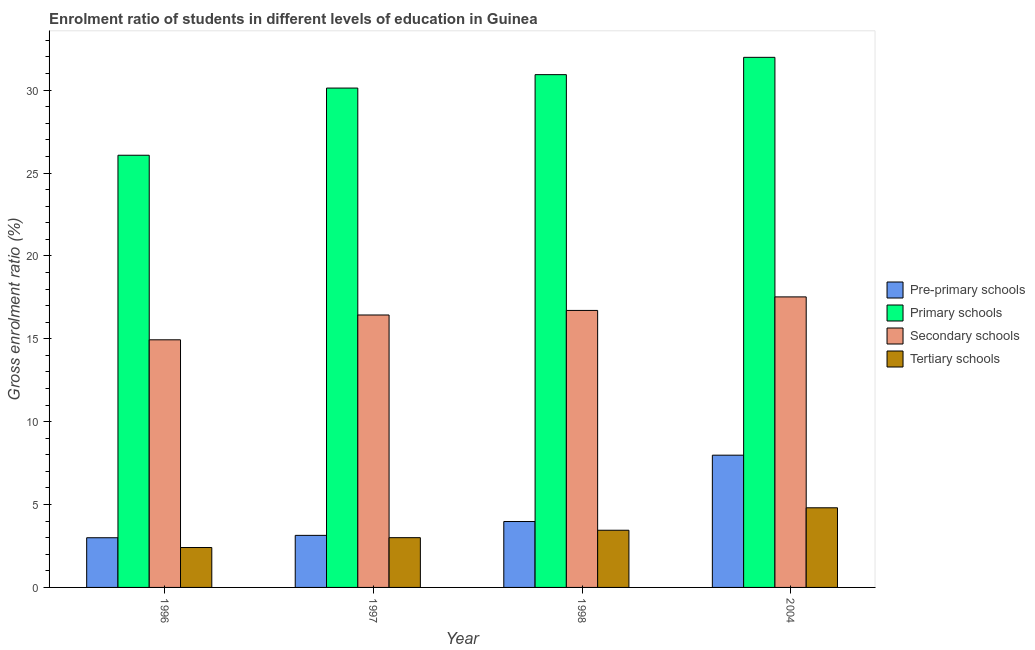Are the number of bars per tick equal to the number of legend labels?
Give a very brief answer. Yes. How many bars are there on the 4th tick from the left?
Provide a succinct answer. 4. How many bars are there on the 4th tick from the right?
Ensure brevity in your answer.  4. What is the label of the 2nd group of bars from the left?
Your answer should be very brief. 1997. In how many cases, is the number of bars for a given year not equal to the number of legend labels?
Your answer should be compact. 0. What is the gross enrolment ratio in secondary schools in 2004?
Your answer should be very brief. 17.53. Across all years, what is the maximum gross enrolment ratio in primary schools?
Provide a succinct answer. 31.98. Across all years, what is the minimum gross enrolment ratio in secondary schools?
Make the answer very short. 14.94. In which year was the gross enrolment ratio in primary schools minimum?
Make the answer very short. 1996. What is the total gross enrolment ratio in tertiary schools in the graph?
Provide a short and direct response. 13.66. What is the difference between the gross enrolment ratio in secondary schools in 1996 and that in 1998?
Your answer should be compact. -1.77. What is the difference between the gross enrolment ratio in primary schools in 2004 and the gross enrolment ratio in tertiary schools in 1996?
Your answer should be very brief. 5.91. What is the average gross enrolment ratio in pre-primary schools per year?
Your response must be concise. 4.52. In how many years, is the gross enrolment ratio in secondary schools greater than 22 %?
Keep it short and to the point. 0. What is the ratio of the gross enrolment ratio in primary schools in 1998 to that in 2004?
Offer a terse response. 0.97. What is the difference between the highest and the second highest gross enrolment ratio in tertiary schools?
Provide a short and direct response. 1.35. What is the difference between the highest and the lowest gross enrolment ratio in secondary schools?
Offer a very short reply. 2.59. What does the 1st bar from the left in 1996 represents?
Ensure brevity in your answer.  Pre-primary schools. What does the 3rd bar from the right in 2004 represents?
Offer a very short reply. Primary schools. Is it the case that in every year, the sum of the gross enrolment ratio in pre-primary schools and gross enrolment ratio in primary schools is greater than the gross enrolment ratio in secondary schools?
Offer a very short reply. Yes. How many bars are there?
Give a very brief answer. 16. How many years are there in the graph?
Make the answer very short. 4. What is the difference between two consecutive major ticks on the Y-axis?
Your answer should be compact. 5. Are the values on the major ticks of Y-axis written in scientific E-notation?
Offer a very short reply. No. What is the title of the graph?
Provide a succinct answer. Enrolment ratio of students in different levels of education in Guinea. Does "Korea" appear as one of the legend labels in the graph?
Give a very brief answer. No. What is the label or title of the X-axis?
Your answer should be compact. Year. What is the label or title of the Y-axis?
Give a very brief answer. Gross enrolment ratio (%). What is the Gross enrolment ratio (%) in Pre-primary schools in 1996?
Make the answer very short. 3. What is the Gross enrolment ratio (%) in Primary schools in 1996?
Your answer should be very brief. 26.07. What is the Gross enrolment ratio (%) of Secondary schools in 1996?
Make the answer very short. 14.94. What is the Gross enrolment ratio (%) of Tertiary schools in 1996?
Your answer should be very brief. 2.41. What is the Gross enrolment ratio (%) of Pre-primary schools in 1997?
Keep it short and to the point. 3.14. What is the Gross enrolment ratio (%) in Primary schools in 1997?
Provide a succinct answer. 30.12. What is the Gross enrolment ratio (%) of Secondary schools in 1997?
Make the answer very short. 16.44. What is the Gross enrolment ratio (%) of Tertiary schools in 1997?
Provide a succinct answer. 3. What is the Gross enrolment ratio (%) in Pre-primary schools in 1998?
Offer a terse response. 3.98. What is the Gross enrolment ratio (%) in Primary schools in 1998?
Make the answer very short. 30.93. What is the Gross enrolment ratio (%) in Secondary schools in 1998?
Give a very brief answer. 16.71. What is the Gross enrolment ratio (%) of Tertiary schools in 1998?
Your response must be concise. 3.45. What is the Gross enrolment ratio (%) of Pre-primary schools in 2004?
Your answer should be compact. 7.98. What is the Gross enrolment ratio (%) in Primary schools in 2004?
Provide a short and direct response. 31.98. What is the Gross enrolment ratio (%) in Secondary schools in 2004?
Make the answer very short. 17.53. What is the Gross enrolment ratio (%) of Tertiary schools in 2004?
Your answer should be compact. 4.8. Across all years, what is the maximum Gross enrolment ratio (%) of Pre-primary schools?
Offer a terse response. 7.98. Across all years, what is the maximum Gross enrolment ratio (%) of Primary schools?
Offer a very short reply. 31.98. Across all years, what is the maximum Gross enrolment ratio (%) of Secondary schools?
Offer a terse response. 17.53. Across all years, what is the maximum Gross enrolment ratio (%) in Tertiary schools?
Keep it short and to the point. 4.8. Across all years, what is the minimum Gross enrolment ratio (%) in Pre-primary schools?
Provide a succinct answer. 3. Across all years, what is the minimum Gross enrolment ratio (%) in Primary schools?
Your answer should be very brief. 26.07. Across all years, what is the minimum Gross enrolment ratio (%) of Secondary schools?
Your answer should be compact. 14.94. Across all years, what is the minimum Gross enrolment ratio (%) in Tertiary schools?
Your response must be concise. 2.41. What is the total Gross enrolment ratio (%) of Pre-primary schools in the graph?
Provide a short and direct response. 18.09. What is the total Gross enrolment ratio (%) of Primary schools in the graph?
Ensure brevity in your answer.  119.11. What is the total Gross enrolment ratio (%) of Secondary schools in the graph?
Your answer should be compact. 65.61. What is the total Gross enrolment ratio (%) of Tertiary schools in the graph?
Make the answer very short. 13.66. What is the difference between the Gross enrolment ratio (%) of Pre-primary schools in 1996 and that in 1997?
Offer a very short reply. -0.14. What is the difference between the Gross enrolment ratio (%) of Primary schools in 1996 and that in 1997?
Offer a terse response. -4.05. What is the difference between the Gross enrolment ratio (%) in Secondary schools in 1996 and that in 1997?
Ensure brevity in your answer.  -1.5. What is the difference between the Gross enrolment ratio (%) in Tertiary schools in 1996 and that in 1997?
Provide a succinct answer. -0.59. What is the difference between the Gross enrolment ratio (%) in Pre-primary schools in 1996 and that in 1998?
Offer a terse response. -0.98. What is the difference between the Gross enrolment ratio (%) in Primary schools in 1996 and that in 1998?
Provide a short and direct response. -4.86. What is the difference between the Gross enrolment ratio (%) of Secondary schools in 1996 and that in 1998?
Your response must be concise. -1.77. What is the difference between the Gross enrolment ratio (%) of Tertiary schools in 1996 and that in 1998?
Make the answer very short. -1.04. What is the difference between the Gross enrolment ratio (%) in Pre-primary schools in 1996 and that in 2004?
Offer a terse response. -4.98. What is the difference between the Gross enrolment ratio (%) of Primary schools in 1996 and that in 2004?
Your answer should be very brief. -5.91. What is the difference between the Gross enrolment ratio (%) of Secondary schools in 1996 and that in 2004?
Your answer should be compact. -2.59. What is the difference between the Gross enrolment ratio (%) in Tertiary schools in 1996 and that in 2004?
Provide a short and direct response. -2.4. What is the difference between the Gross enrolment ratio (%) of Pre-primary schools in 1997 and that in 1998?
Your answer should be compact. -0.83. What is the difference between the Gross enrolment ratio (%) in Primary schools in 1997 and that in 1998?
Give a very brief answer. -0.81. What is the difference between the Gross enrolment ratio (%) of Secondary schools in 1997 and that in 1998?
Offer a very short reply. -0.27. What is the difference between the Gross enrolment ratio (%) in Tertiary schools in 1997 and that in 1998?
Offer a terse response. -0.45. What is the difference between the Gross enrolment ratio (%) of Pre-primary schools in 1997 and that in 2004?
Provide a short and direct response. -4.84. What is the difference between the Gross enrolment ratio (%) in Primary schools in 1997 and that in 2004?
Provide a short and direct response. -1.85. What is the difference between the Gross enrolment ratio (%) in Secondary schools in 1997 and that in 2004?
Offer a very short reply. -1.09. What is the difference between the Gross enrolment ratio (%) in Tertiary schools in 1997 and that in 2004?
Your answer should be compact. -1.8. What is the difference between the Gross enrolment ratio (%) in Pre-primary schools in 1998 and that in 2004?
Your response must be concise. -4. What is the difference between the Gross enrolment ratio (%) of Primary schools in 1998 and that in 2004?
Provide a short and direct response. -1.04. What is the difference between the Gross enrolment ratio (%) of Secondary schools in 1998 and that in 2004?
Provide a short and direct response. -0.82. What is the difference between the Gross enrolment ratio (%) in Tertiary schools in 1998 and that in 2004?
Keep it short and to the point. -1.35. What is the difference between the Gross enrolment ratio (%) in Pre-primary schools in 1996 and the Gross enrolment ratio (%) in Primary schools in 1997?
Offer a very short reply. -27.13. What is the difference between the Gross enrolment ratio (%) of Pre-primary schools in 1996 and the Gross enrolment ratio (%) of Secondary schools in 1997?
Offer a terse response. -13.44. What is the difference between the Gross enrolment ratio (%) in Pre-primary schools in 1996 and the Gross enrolment ratio (%) in Tertiary schools in 1997?
Your response must be concise. -0. What is the difference between the Gross enrolment ratio (%) in Primary schools in 1996 and the Gross enrolment ratio (%) in Secondary schools in 1997?
Your response must be concise. 9.64. What is the difference between the Gross enrolment ratio (%) in Primary schools in 1996 and the Gross enrolment ratio (%) in Tertiary schools in 1997?
Provide a succinct answer. 23.07. What is the difference between the Gross enrolment ratio (%) in Secondary schools in 1996 and the Gross enrolment ratio (%) in Tertiary schools in 1997?
Your response must be concise. 11.94. What is the difference between the Gross enrolment ratio (%) in Pre-primary schools in 1996 and the Gross enrolment ratio (%) in Primary schools in 1998?
Give a very brief answer. -27.94. What is the difference between the Gross enrolment ratio (%) in Pre-primary schools in 1996 and the Gross enrolment ratio (%) in Secondary schools in 1998?
Give a very brief answer. -13.71. What is the difference between the Gross enrolment ratio (%) of Pre-primary schools in 1996 and the Gross enrolment ratio (%) of Tertiary schools in 1998?
Keep it short and to the point. -0.45. What is the difference between the Gross enrolment ratio (%) in Primary schools in 1996 and the Gross enrolment ratio (%) in Secondary schools in 1998?
Your answer should be very brief. 9.36. What is the difference between the Gross enrolment ratio (%) in Primary schools in 1996 and the Gross enrolment ratio (%) in Tertiary schools in 1998?
Offer a terse response. 22.62. What is the difference between the Gross enrolment ratio (%) in Secondary schools in 1996 and the Gross enrolment ratio (%) in Tertiary schools in 1998?
Provide a short and direct response. 11.49. What is the difference between the Gross enrolment ratio (%) of Pre-primary schools in 1996 and the Gross enrolment ratio (%) of Primary schools in 2004?
Make the answer very short. -28.98. What is the difference between the Gross enrolment ratio (%) of Pre-primary schools in 1996 and the Gross enrolment ratio (%) of Secondary schools in 2004?
Make the answer very short. -14.53. What is the difference between the Gross enrolment ratio (%) of Pre-primary schools in 1996 and the Gross enrolment ratio (%) of Tertiary schools in 2004?
Offer a terse response. -1.81. What is the difference between the Gross enrolment ratio (%) of Primary schools in 1996 and the Gross enrolment ratio (%) of Secondary schools in 2004?
Your answer should be very brief. 8.55. What is the difference between the Gross enrolment ratio (%) in Primary schools in 1996 and the Gross enrolment ratio (%) in Tertiary schools in 2004?
Make the answer very short. 21.27. What is the difference between the Gross enrolment ratio (%) in Secondary schools in 1996 and the Gross enrolment ratio (%) in Tertiary schools in 2004?
Provide a succinct answer. 10.13. What is the difference between the Gross enrolment ratio (%) in Pre-primary schools in 1997 and the Gross enrolment ratio (%) in Primary schools in 1998?
Your answer should be very brief. -27.79. What is the difference between the Gross enrolment ratio (%) of Pre-primary schools in 1997 and the Gross enrolment ratio (%) of Secondary schools in 1998?
Offer a very short reply. -13.57. What is the difference between the Gross enrolment ratio (%) of Pre-primary schools in 1997 and the Gross enrolment ratio (%) of Tertiary schools in 1998?
Offer a terse response. -0.31. What is the difference between the Gross enrolment ratio (%) of Primary schools in 1997 and the Gross enrolment ratio (%) of Secondary schools in 1998?
Make the answer very short. 13.41. What is the difference between the Gross enrolment ratio (%) of Primary schools in 1997 and the Gross enrolment ratio (%) of Tertiary schools in 1998?
Give a very brief answer. 26.67. What is the difference between the Gross enrolment ratio (%) in Secondary schools in 1997 and the Gross enrolment ratio (%) in Tertiary schools in 1998?
Keep it short and to the point. 12.98. What is the difference between the Gross enrolment ratio (%) of Pre-primary schools in 1997 and the Gross enrolment ratio (%) of Primary schools in 2004?
Your answer should be compact. -28.84. What is the difference between the Gross enrolment ratio (%) of Pre-primary schools in 1997 and the Gross enrolment ratio (%) of Secondary schools in 2004?
Keep it short and to the point. -14.39. What is the difference between the Gross enrolment ratio (%) of Pre-primary schools in 1997 and the Gross enrolment ratio (%) of Tertiary schools in 2004?
Provide a short and direct response. -1.66. What is the difference between the Gross enrolment ratio (%) of Primary schools in 1997 and the Gross enrolment ratio (%) of Secondary schools in 2004?
Your answer should be very brief. 12.6. What is the difference between the Gross enrolment ratio (%) of Primary schools in 1997 and the Gross enrolment ratio (%) of Tertiary schools in 2004?
Offer a terse response. 25.32. What is the difference between the Gross enrolment ratio (%) in Secondary schools in 1997 and the Gross enrolment ratio (%) in Tertiary schools in 2004?
Offer a very short reply. 11.63. What is the difference between the Gross enrolment ratio (%) in Pre-primary schools in 1998 and the Gross enrolment ratio (%) in Primary schools in 2004?
Provide a short and direct response. -28. What is the difference between the Gross enrolment ratio (%) in Pre-primary schools in 1998 and the Gross enrolment ratio (%) in Secondary schools in 2004?
Provide a short and direct response. -13.55. What is the difference between the Gross enrolment ratio (%) in Pre-primary schools in 1998 and the Gross enrolment ratio (%) in Tertiary schools in 2004?
Offer a terse response. -0.83. What is the difference between the Gross enrolment ratio (%) in Primary schools in 1998 and the Gross enrolment ratio (%) in Secondary schools in 2004?
Make the answer very short. 13.41. What is the difference between the Gross enrolment ratio (%) of Primary schools in 1998 and the Gross enrolment ratio (%) of Tertiary schools in 2004?
Give a very brief answer. 26.13. What is the difference between the Gross enrolment ratio (%) in Secondary schools in 1998 and the Gross enrolment ratio (%) in Tertiary schools in 2004?
Ensure brevity in your answer.  11.91. What is the average Gross enrolment ratio (%) in Pre-primary schools per year?
Your response must be concise. 4.52. What is the average Gross enrolment ratio (%) of Primary schools per year?
Offer a very short reply. 29.78. What is the average Gross enrolment ratio (%) in Secondary schools per year?
Provide a succinct answer. 16.4. What is the average Gross enrolment ratio (%) of Tertiary schools per year?
Provide a succinct answer. 3.42. In the year 1996, what is the difference between the Gross enrolment ratio (%) of Pre-primary schools and Gross enrolment ratio (%) of Primary schools?
Your answer should be very brief. -23.07. In the year 1996, what is the difference between the Gross enrolment ratio (%) of Pre-primary schools and Gross enrolment ratio (%) of Secondary schools?
Offer a very short reply. -11.94. In the year 1996, what is the difference between the Gross enrolment ratio (%) in Pre-primary schools and Gross enrolment ratio (%) in Tertiary schools?
Offer a very short reply. 0.59. In the year 1996, what is the difference between the Gross enrolment ratio (%) in Primary schools and Gross enrolment ratio (%) in Secondary schools?
Provide a succinct answer. 11.13. In the year 1996, what is the difference between the Gross enrolment ratio (%) in Primary schools and Gross enrolment ratio (%) in Tertiary schools?
Make the answer very short. 23.66. In the year 1996, what is the difference between the Gross enrolment ratio (%) of Secondary schools and Gross enrolment ratio (%) of Tertiary schools?
Ensure brevity in your answer.  12.53. In the year 1997, what is the difference between the Gross enrolment ratio (%) in Pre-primary schools and Gross enrolment ratio (%) in Primary schools?
Give a very brief answer. -26.98. In the year 1997, what is the difference between the Gross enrolment ratio (%) in Pre-primary schools and Gross enrolment ratio (%) in Secondary schools?
Your answer should be very brief. -13.29. In the year 1997, what is the difference between the Gross enrolment ratio (%) in Pre-primary schools and Gross enrolment ratio (%) in Tertiary schools?
Ensure brevity in your answer.  0.14. In the year 1997, what is the difference between the Gross enrolment ratio (%) in Primary schools and Gross enrolment ratio (%) in Secondary schools?
Ensure brevity in your answer.  13.69. In the year 1997, what is the difference between the Gross enrolment ratio (%) of Primary schools and Gross enrolment ratio (%) of Tertiary schools?
Your answer should be compact. 27.12. In the year 1997, what is the difference between the Gross enrolment ratio (%) in Secondary schools and Gross enrolment ratio (%) in Tertiary schools?
Ensure brevity in your answer.  13.43. In the year 1998, what is the difference between the Gross enrolment ratio (%) in Pre-primary schools and Gross enrolment ratio (%) in Primary schools?
Your answer should be very brief. -26.96. In the year 1998, what is the difference between the Gross enrolment ratio (%) of Pre-primary schools and Gross enrolment ratio (%) of Secondary schools?
Give a very brief answer. -12.73. In the year 1998, what is the difference between the Gross enrolment ratio (%) in Pre-primary schools and Gross enrolment ratio (%) in Tertiary schools?
Ensure brevity in your answer.  0.53. In the year 1998, what is the difference between the Gross enrolment ratio (%) in Primary schools and Gross enrolment ratio (%) in Secondary schools?
Give a very brief answer. 14.22. In the year 1998, what is the difference between the Gross enrolment ratio (%) of Primary schools and Gross enrolment ratio (%) of Tertiary schools?
Your response must be concise. 27.48. In the year 1998, what is the difference between the Gross enrolment ratio (%) of Secondary schools and Gross enrolment ratio (%) of Tertiary schools?
Give a very brief answer. 13.26. In the year 2004, what is the difference between the Gross enrolment ratio (%) of Pre-primary schools and Gross enrolment ratio (%) of Primary schools?
Your answer should be very brief. -24. In the year 2004, what is the difference between the Gross enrolment ratio (%) in Pre-primary schools and Gross enrolment ratio (%) in Secondary schools?
Your response must be concise. -9.55. In the year 2004, what is the difference between the Gross enrolment ratio (%) of Pre-primary schools and Gross enrolment ratio (%) of Tertiary schools?
Your answer should be compact. 3.17. In the year 2004, what is the difference between the Gross enrolment ratio (%) of Primary schools and Gross enrolment ratio (%) of Secondary schools?
Your response must be concise. 14.45. In the year 2004, what is the difference between the Gross enrolment ratio (%) in Primary schools and Gross enrolment ratio (%) in Tertiary schools?
Your answer should be very brief. 27.17. In the year 2004, what is the difference between the Gross enrolment ratio (%) of Secondary schools and Gross enrolment ratio (%) of Tertiary schools?
Your response must be concise. 12.72. What is the ratio of the Gross enrolment ratio (%) in Pre-primary schools in 1996 to that in 1997?
Provide a succinct answer. 0.95. What is the ratio of the Gross enrolment ratio (%) of Primary schools in 1996 to that in 1997?
Make the answer very short. 0.87. What is the ratio of the Gross enrolment ratio (%) in Secondary schools in 1996 to that in 1997?
Offer a very short reply. 0.91. What is the ratio of the Gross enrolment ratio (%) of Tertiary schools in 1996 to that in 1997?
Keep it short and to the point. 0.8. What is the ratio of the Gross enrolment ratio (%) in Pre-primary schools in 1996 to that in 1998?
Keep it short and to the point. 0.75. What is the ratio of the Gross enrolment ratio (%) of Primary schools in 1996 to that in 1998?
Provide a short and direct response. 0.84. What is the ratio of the Gross enrolment ratio (%) in Secondary schools in 1996 to that in 1998?
Your response must be concise. 0.89. What is the ratio of the Gross enrolment ratio (%) of Tertiary schools in 1996 to that in 1998?
Your response must be concise. 0.7. What is the ratio of the Gross enrolment ratio (%) of Pre-primary schools in 1996 to that in 2004?
Ensure brevity in your answer.  0.38. What is the ratio of the Gross enrolment ratio (%) of Primary schools in 1996 to that in 2004?
Your answer should be very brief. 0.82. What is the ratio of the Gross enrolment ratio (%) of Secondary schools in 1996 to that in 2004?
Ensure brevity in your answer.  0.85. What is the ratio of the Gross enrolment ratio (%) in Tertiary schools in 1996 to that in 2004?
Your answer should be very brief. 0.5. What is the ratio of the Gross enrolment ratio (%) of Pre-primary schools in 1997 to that in 1998?
Provide a short and direct response. 0.79. What is the ratio of the Gross enrolment ratio (%) in Primary schools in 1997 to that in 1998?
Make the answer very short. 0.97. What is the ratio of the Gross enrolment ratio (%) of Secondary schools in 1997 to that in 1998?
Keep it short and to the point. 0.98. What is the ratio of the Gross enrolment ratio (%) of Tertiary schools in 1997 to that in 1998?
Give a very brief answer. 0.87. What is the ratio of the Gross enrolment ratio (%) of Pre-primary schools in 1997 to that in 2004?
Offer a terse response. 0.39. What is the ratio of the Gross enrolment ratio (%) in Primary schools in 1997 to that in 2004?
Make the answer very short. 0.94. What is the ratio of the Gross enrolment ratio (%) of Secondary schools in 1997 to that in 2004?
Make the answer very short. 0.94. What is the ratio of the Gross enrolment ratio (%) of Tertiary schools in 1997 to that in 2004?
Provide a succinct answer. 0.62. What is the ratio of the Gross enrolment ratio (%) in Pre-primary schools in 1998 to that in 2004?
Your answer should be very brief. 0.5. What is the ratio of the Gross enrolment ratio (%) of Primary schools in 1998 to that in 2004?
Provide a succinct answer. 0.97. What is the ratio of the Gross enrolment ratio (%) in Secondary schools in 1998 to that in 2004?
Your answer should be compact. 0.95. What is the ratio of the Gross enrolment ratio (%) in Tertiary schools in 1998 to that in 2004?
Make the answer very short. 0.72. What is the difference between the highest and the second highest Gross enrolment ratio (%) of Pre-primary schools?
Your answer should be very brief. 4. What is the difference between the highest and the second highest Gross enrolment ratio (%) in Primary schools?
Keep it short and to the point. 1.04. What is the difference between the highest and the second highest Gross enrolment ratio (%) in Secondary schools?
Give a very brief answer. 0.82. What is the difference between the highest and the second highest Gross enrolment ratio (%) in Tertiary schools?
Your response must be concise. 1.35. What is the difference between the highest and the lowest Gross enrolment ratio (%) in Pre-primary schools?
Make the answer very short. 4.98. What is the difference between the highest and the lowest Gross enrolment ratio (%) in Primary schools?
Offer a very short reply. 5.91. What is the difference between the highest and the lowest Gross enrolment ratio (%) in Secondary schools?
Keep it short and to the point. 2.59. What is the difference between the highest and the lowest Gross enrolment ratio (%) in Tertiary schools?
Give a very brief answer. 2.4. 